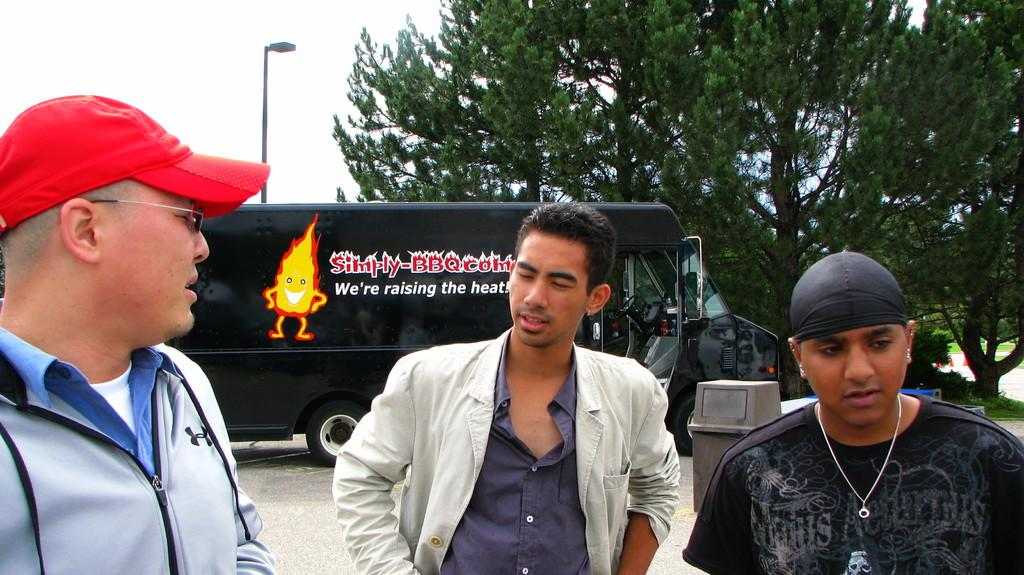How many people are present in the image? There are three people standing in the image. What can be seen in the background of the image? There is a bus, trees, a trash can, and a light pole in the background of the image. What type of skin can be seen on the trees in the image? There is no mention of the type of skin on the trees in the image, as trees do not have skin. 